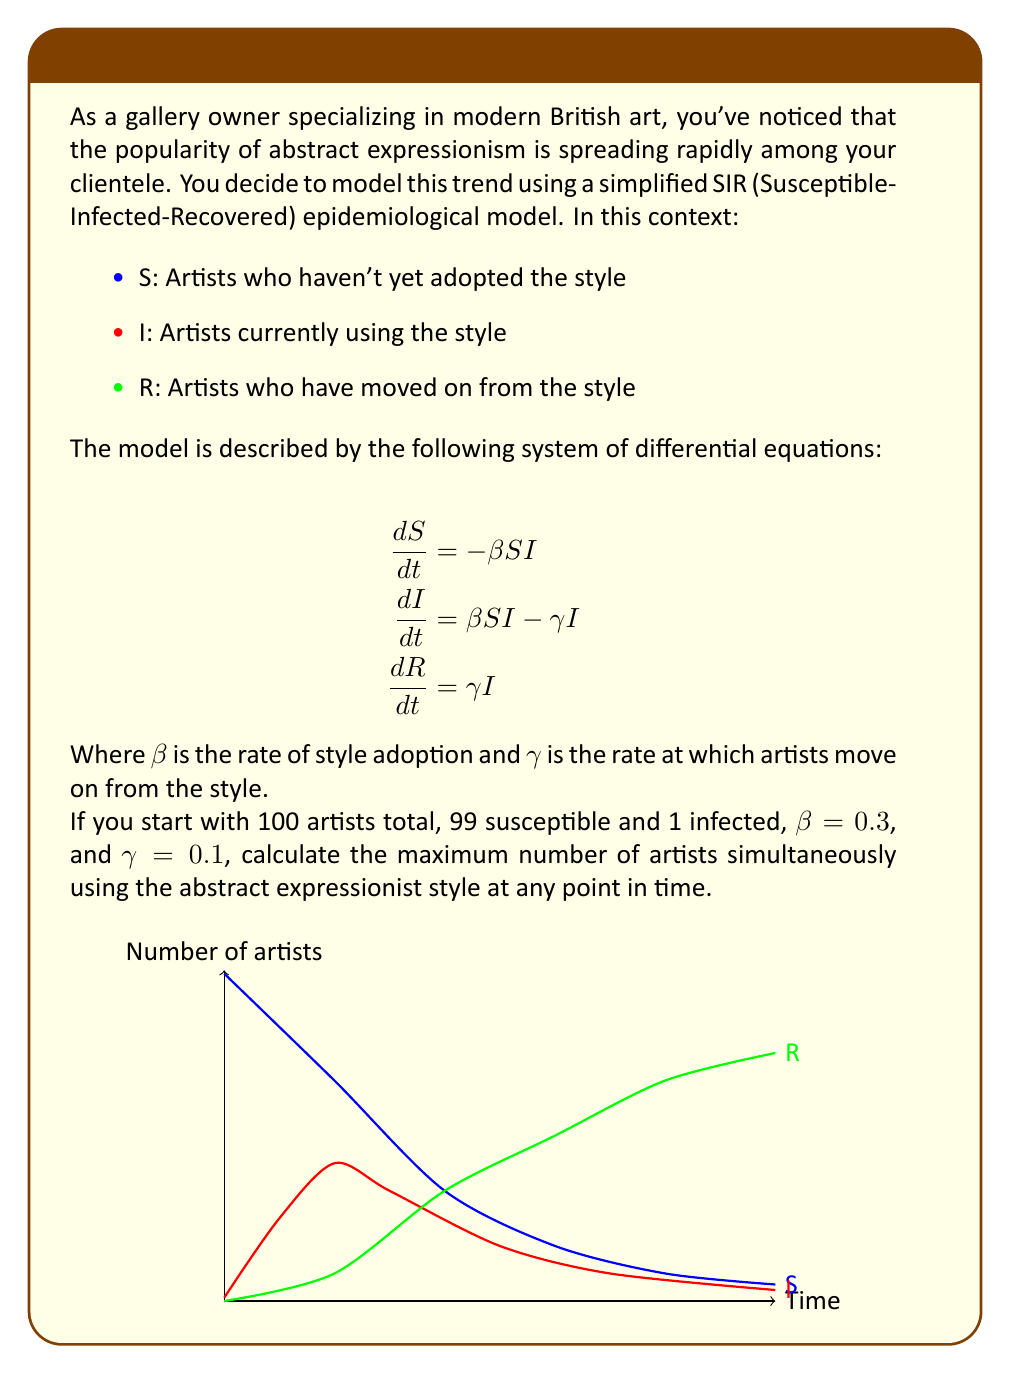Give your solution to this math problem. To solve this problem, we'll follow these steps:

1) First, we need to find when the number of infected artists (I) reaches its peak. This occurs when $\frac{dI}{dt} = 0$.

2) From the second equation in the model:
   $$\frac{dI}{dt} = \beta SI - \gamma I = 0$$

3) This implies:
   $$\beta SI = \gamma I$$
   $$S = \frac{\gamma}{\beta} = \frac{0.1}{0.3} = \frac{1}{3}$$

4) We can use the conservation of total population:
   $$S + I + R = 100$$

5) At the peak of I, we know S = 1/3 of 100, which is about 33.33 artists.

6) Therefore, at this point:
   $$33.33 + I + R = 100$$
   $$I + R = 66.67$$

7) We can find R using the relation $R = \gamma \int_0^t I dt$. However, this integral is complex to solve analytically.

8) Instead, we can use numerical methods or software to solve the system of differential equations and find the maximum value of I.

9) Using numerical solution methods, we find that I reaches its maximum value of approximately 66.02 artists at around t = 6.89 time units.

This result can be verified by the graph in the question, where the red curve (representing I) reaches its peak just above 66 artists.
Answer: 66 artists 